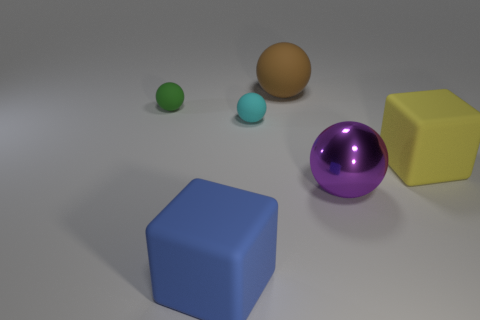Are there any other things that have the same material as the purple object?
Ensure brevity in your answer.  No. Are there more large blue matte objects in front of the yellow matte cube than small cyan metallic blocks?
Offer a very short reply. Yes. What color is the big matte cube on the left side of the brown rubber thing?
Offer a terse response. Blue. How many matte objects are tiny balls or spheres?
Your response must be concise. 3. Are there any yellow objects to the right of the large thing left of the big ball on the left side of the metallic object?
Provide a short and direct response. Yes. There is a green sphere; what number of brown spheres are behind it?
Your answer should be compact. 1. What number of big things are either blue blocks or purple shiny spheres?
Ensure brevity in your answer.  2. There is a tiny matte object that is left of the small cyan thing; what shape is it?
Your answer should be compact. Sphere. There is a matte ball right of the small cyan matte sphere; does it have the same size as the matte object that is left of the large blue matte thing?
Offer a very short reply. No. Are there more tiny matte spheres that are to the right of the green rubber object than big brown matte things in front of the big yellow matte thing?
Provide a short and direct response. Yes. 